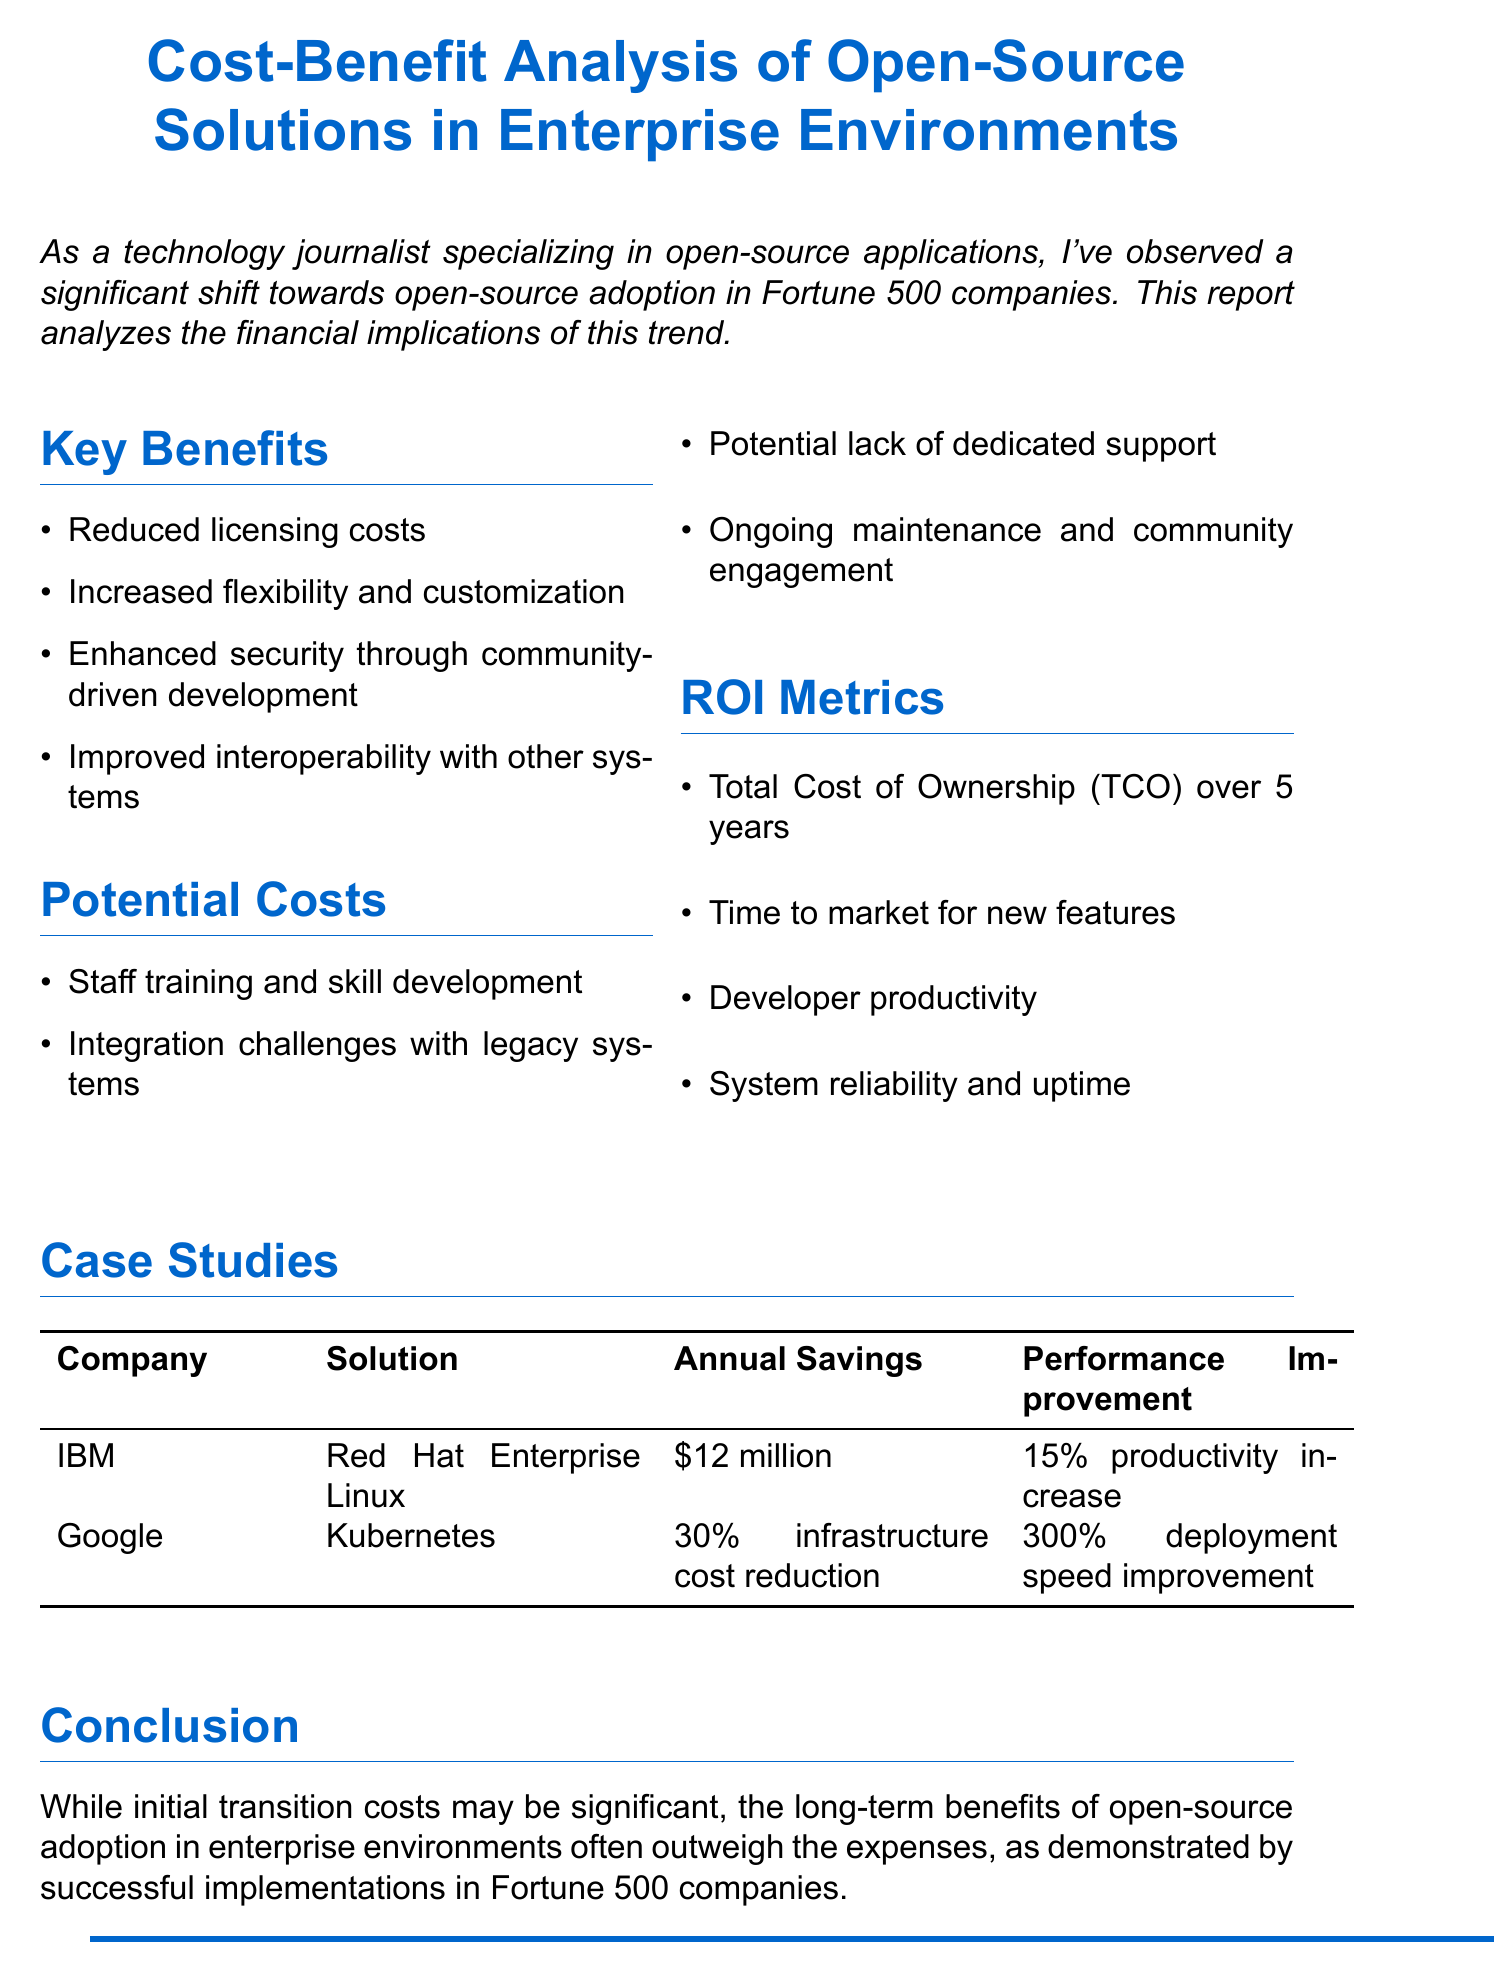What is the title of the report? The title of the report is stated clearly at the beginning of the document.
Answer: Cost-Benefit Analysis of Open-Source Solutions in Enterprise Environments What noteworthy solution did IBM adopt? The document highlights specific solutions adopted by companies, with IBM noted for using Red Hat Enterprise Linux.
Answer: Red Hat Enterprise Linux What is the annual savings achieved by IBM? The annual savings is explicitly mentioned in the case study section of the document.
Answer: $12 million What percentage increase in productivity did IBM experience? This information is provided alongside the savings in the case studies of the document.
Answer: 15% What key benefit emphasizes security? The document lists benefits, among which one specifically discusses security improvements.
Answer: Enhanced security through community-driven development What are potential costs associated with adopting open-source solutions? The potential costs are listed in a dedicated section of the document, highlighting challenges encountered.
Answer: Staff training and skill development Which company realized a 300% improvement in deployment speed? The report contains specific performance improvements for companies using open-source solutions.
Answer: Google What is one of the ROI metrics mentioned? The document lists several return on investment metrics that companies may consider.
Answer: Total Cost of Ownership (TCO) over 5 years What does the conclusion suggest about initial transition costs? The conclusion summarizes the analysis while mentioning initial transition costs relative to long-term benefits.
Answer: Significant 